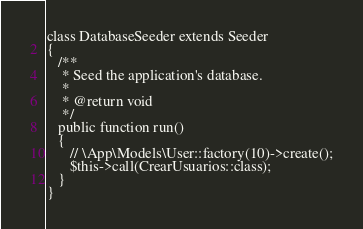Convert code to text. <code><loc_0><loc_0><loc_500><loc_500><_PHP_>class DatabaseSeeder extends Seeder
{
   /**
    * Seed the application's database.
    *
    * @return void
    */
   public function run()
   {
      // \App\Models\User::factory(10)->create();
      $this->call(CrearUsuarios::class);
   }
}
</code> 